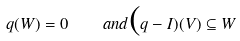Convert formula to latex. <formula><loc_0><loc_0><loc_500><loc_500>q ( W ) = 0 \quad a n d \mbox ( q - I ) ( V ) \subseteq W</formula> 